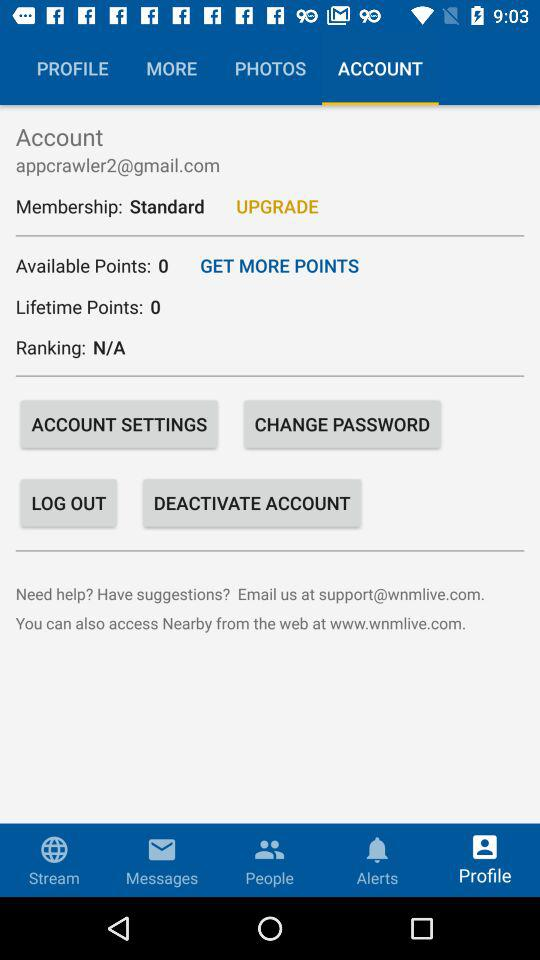How many lifetime points are there? There are 0 lifetime points. 